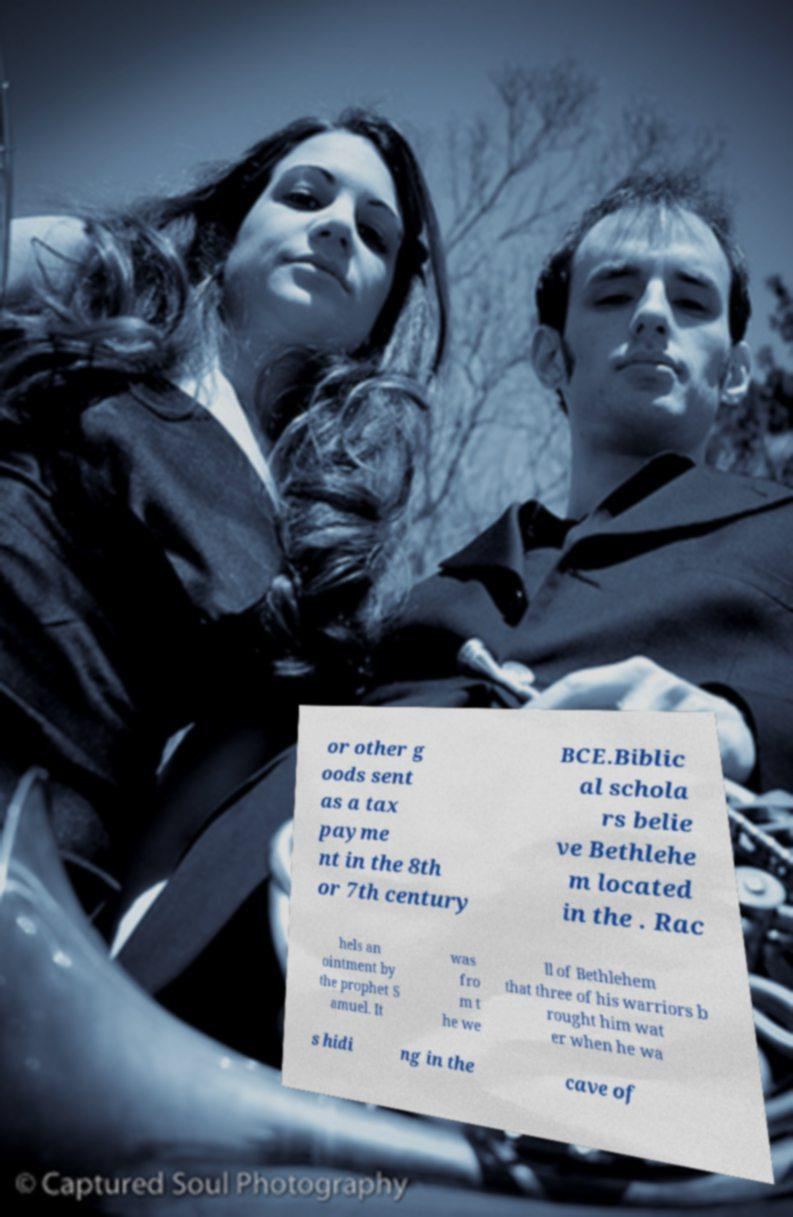Can you accurately transcribe the text from the provided image for me? or other g oods sent as a tax payme nt in the 8th or 7th century BCE.Biblic al schola rs belie ve Bethlehe m located in the . Rac hels an ointment by the prophet S amuel. It was fro m t he we ll of Bethlehem that three of his warriors b rought him wat er when he wa s hidi ng in the cave of 